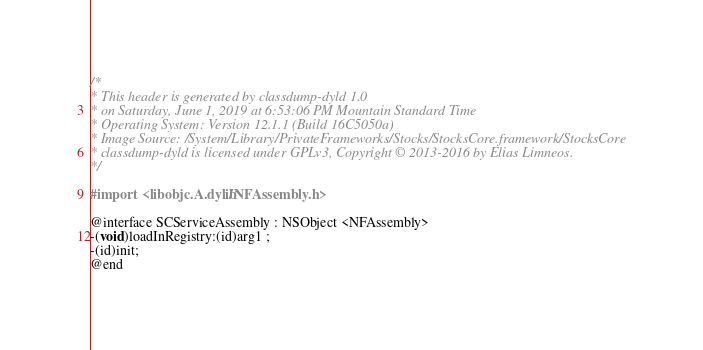<code> <loc_0><loc_0><loc_500><loc_500><_C_>/*
* This header is generated by classdump-dyld 1.0
* on Saturday, June 1, 2019 at 6:53:06 PM Mountain Standard Time
* Operating System: Version 12.1.1 (Build 16C5050a)
* Image Source: /System/Library/PrivateFrameworks/Stocks/StocksCore.framework/StocksCore
* classdump-dyld is licensed under GPLv3, Copyright © 2013-2016 by Elias Limneos.
*/

#import <libobjc.A.dylib/NFAssembly.h>

@interface SCServiceAssembly : NSObject <NFAssembly>
-(void)loadInRegistry:(id)arg1 ;
-(id)init;
@end

</code> 